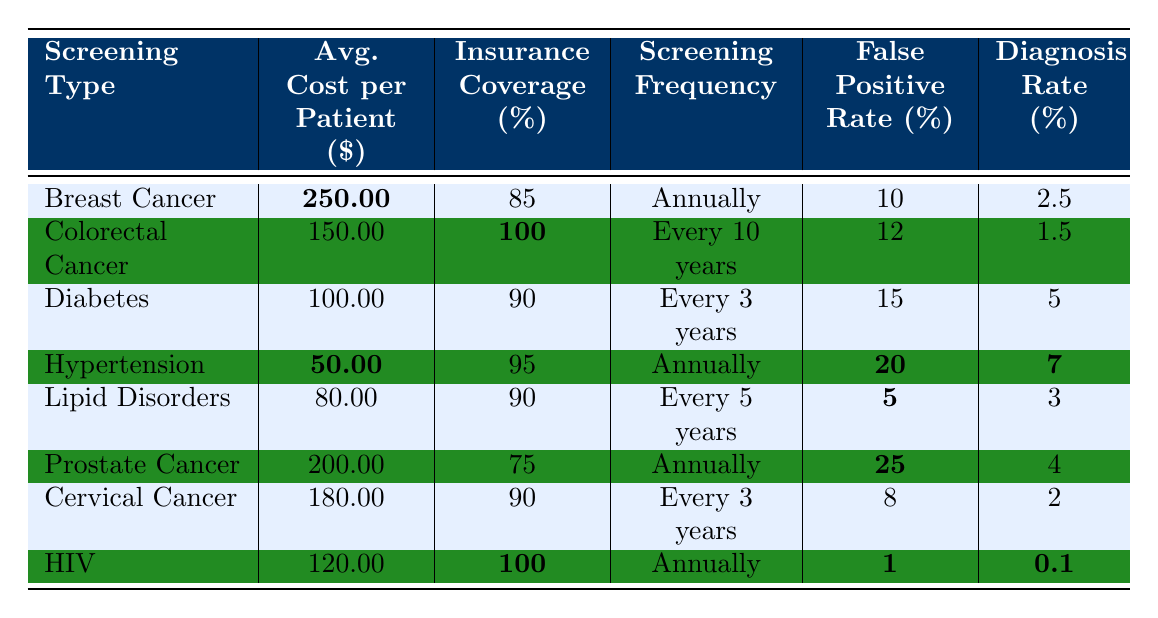What is the average cost per patient for Breast Cancer Screening? The table lists the average cost per patient for Breast Cancer Screening as $250.00 in the corresponding row.
Answer: 250.00 Which screening type has an insurance coverage rate of 100%? The table indicates that both Colorectal Cancer Screening and HIV Screening have an insurance coverage rate of 100% as shown in their respective rows.
Answer: Colorectal Cancer Screening and HIV Screening What is the false positive rate for Diabetes Screening? The false positive rate for Diabetes Screening is provided as 15% in the table, according to the relevant entry.
Answer: 15 Which screening type is the least expensive on average? Comparing the average costs listed, Hypertension Screening is the least expensive at $50.00.
Answer: 50.00 What is the average diagnosis rate for Cervical Cancer Screening and Prostate Cancer Screening combined? To find the average, we take the diagnosis rates (2% for Cervical and 4% for Prostate), sum them (2 + 4 = 6), and divide by 2 (6/2 = 3). Therefore, the average diagnosis rate is 3%.
Answer: 3 Is the average cost per patient for Lipid Disorders Screening lower than for Diabetes Screening? The average cost for Lipid Disorders Screening is $80.00 and for Diabetes Screening is $100.00. Since $80.00 is less than $100.00, the statement is true.
Answer: Yes What is the difference in average cost per patient between Breast Cancer Screening and Prostate Cancer Screening? The average cost for Breast Cancer Screening is $250.00 and for Prostate Cancer Screening it is $200.00. Thus, the difference is calculated as 250 - 200 = 50.
Answer: 50 Which screening type has both the highest false positive rate and lowest diagnosis rate? Prostate Cancer Screening has the highest false positive rate at 25% and a diagnosis rate of 4%. In comparison, Cervical Cancer Screening has a lower false positive rate of 8% and a diagnosis rate of 2%. Therefore, Prostate Cancer Screening fits the criteria.
Answer: Prostate Cancer Screening If all screenings happen only annually, which type has the highest average cost per patient? The table shows that Breast Cancer Screening at $250.00 has the highest cost among the annual screenings (Breast Cancer, Hypertension, Prostate Cancer, and HIV).
Answer: Breast Cancer Screening What percentage of insurance coverage does Colorectal Cancer Screening have compared to the average across all screenings? Colorectal Cancer Screening has 100% coverage, while the average insurance coverage across all screenings can be calculated as (85 + 100 + 90 + 95 + 90 + 75 + 90 + 100)/8 = 91.25. Compared to the average, 100% is higher.
Answer: Higher than average 